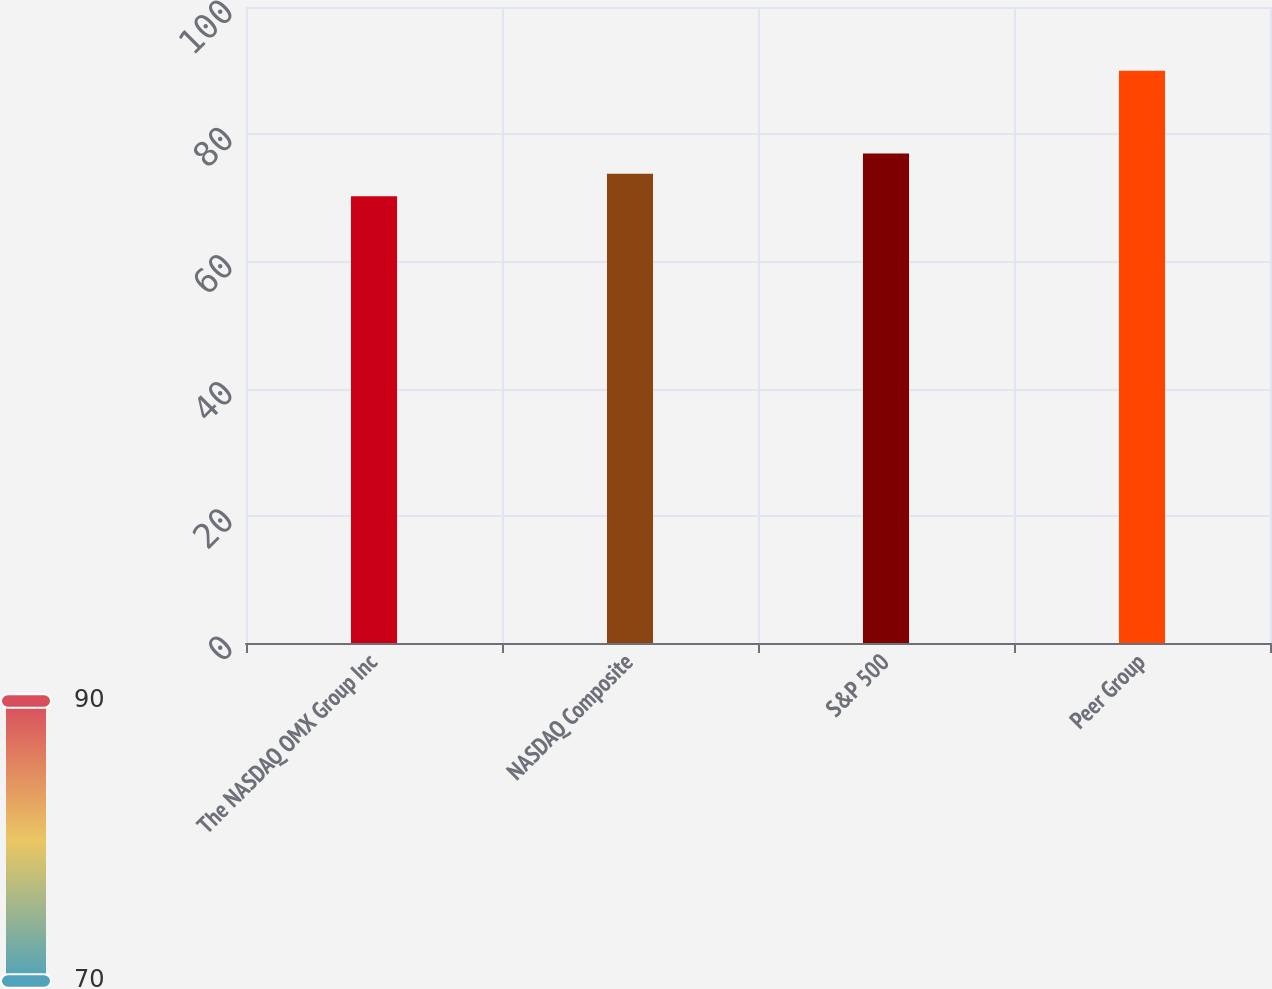Convert chart to OTSL. <chart><loc_0><loc_0><loc_500><loc_500><bar_chart><fcel>The NASDAQ OMX Group Inc<fcel>NASDAQ Composite<fcel>S&P 500<fcel>Peer Group<nl><fcel>70.24<fcel>73.77<fcel>76.96<fcel>89.99<nl></chart> 